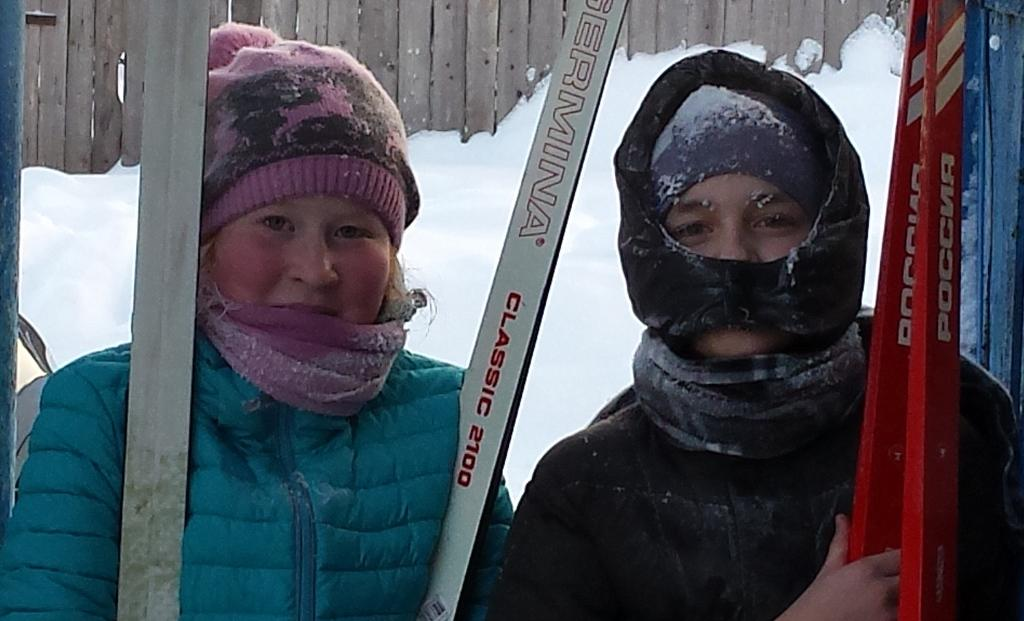How many people are in the image? There are two persons in the image. What are the two persons holding in their hands? The two persons are holding sticks. What type of clothing are the two persons wearing? The two persons are wearing jackets. Can you see a rabbit hopping around the two persons in the image? There is no rabbit present in the image. What type of fruit is the goat eating in the image? There is no goat or fruit present in the image. 